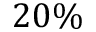Convert formula to latex. <formula><loc_0><loc_0><loc_500><loc_500>2 0 \%</formula> 